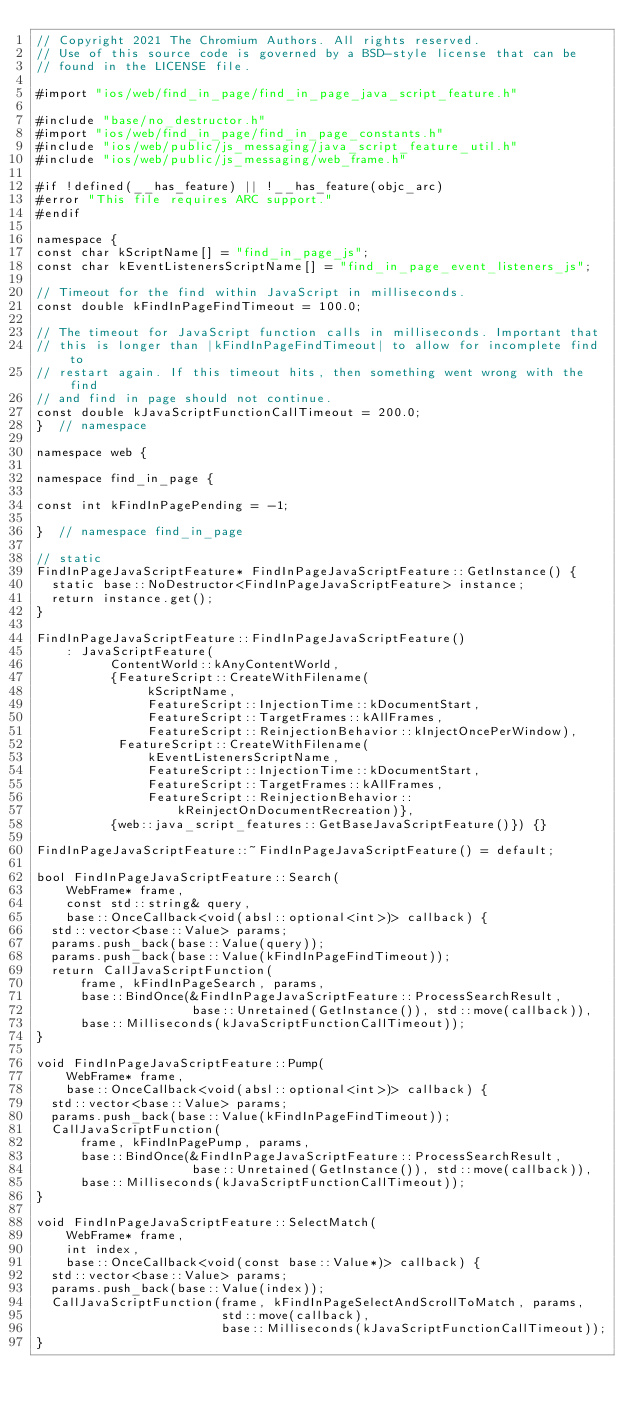Convert code to text. <code><loc_0><loc_0><loc_500><loc_500><_ObjectiveC_>// Copyright 2021 The Chromium Authors. All rights reserved.
// Use of this source code is governed by a BSD-style license that can be
// found in the LICENSE file.

#import "ios/web/find_in_page/find_in_page_java_script_feature.h"

#include "base/no_destructor.h"
#import "ios/web/find_in_page/find_in_page_constants.h"
#include "ios/web/public/js_messaging/java_script_feature_util.h"
#include "ios/web/public/js_messaging/web_frame.h"

#if !defined(__has_feature) || !__has_feature(objc_arc)
#error "This file requires ARC support."
#endif

namespace {
const char kScriptName[] = "find_in_page_js";
const char kEventListenersScriptName[] = "find_in_page_event_listeners_js";

// Timeout for the find within JavaScript in milliseconds.
const double kFindInPageFindTimeout = 100.0;

// The timeout for JavaScript function calls in milliseconds. Important that
// this is longer than |kFindInPageFindTimeout| to allow for incomplete find to
// restart again. If this timeout hits, then something went wrong with the find
// and find in page should not continue.
const double kJavaScriptFunctionCallTimeout = 200.0;
}  // namespace

namespace web {

namespace find_in_page {

const int kFindInPagePending = -1;

}  // namespace find_in_page

// static
FindInPageJavaScriptFeature* FindInPageJavaScriptFeature::GetInstance() {
  static base::NoDestructor<FindInPageJavaScriptFeature> instance;
  return instance.get();
}

FindInPageJavaScriptFeature::FindInPageJavaScriptFeature()
    : JavaScriptFeature(
          ContentWorld::kAnyContentWorld,
          {FeatureScript::CreateWithFilename(
               kScriptName,
               FeatureScript::InjectionTime::kDocumentStart,
               FeatureScript::TargetFrames::kAllFrames,
               FeatureScript::ReinjectionBehavior::kInjectOncePerWindow),
           FeatureScript::CreateWithFilename(
               kEventListenersScriptName,
               FeatureScript::InjectionTime::kDocumentStart,
               FeatureScript::TargetFrames::kAllFrames,
               FeatureScript::ReinjectionBehavior::
                   kReinjectOnDocumentRecreation)},
          {web::java_script_features::GetBaseJavaScriptFeature()}) {}

FindInPageJavaScriptFeature::~FindInPageJavaScriptFeature() = default;

bool FindInPageJavaScriptFeature::Search(
    WebFrame* frame,
    const std::string& query,
    base::OnceCallback<void(absl::optional<int>)> callback) {
  std::vector<base::Value> params;
  params.push_back(base::Value(query));
  params.push_back(base::Value(kFindInPageFindTimeout));
  return CallJavaScriptFunction(
      frame, kFindInPageSearch, params,
      base::BindOnce(&FindInPageJavaScriptFeature::ProcessSearchResult,
                     base::Unretained(GetInstance()), std::move(callback)),
      base::Milliseconds(kJavaScriptFunctionCallTimeout));
}

void FindInPageJavaScriptFeature::Pump(
    WebFrame* frame,
    base::OnceCallback<void(absl::optional<int>)> callback) {
  std::vector<base::Value> params;
  params.push_back(base::Value(kFindInPageFindTimeout));
  CallJavaScriptFunction(
      frame, kFindInPagePump, params,
      base::BindOnce(&FindInPageJavaScriptFeature::ProcessSearchResult,
                     base::Unretained(GetInstance()), std::move(callback)),
      base::Milliseconds(kJavaScriptFunctionCallTimeout));
}

void FindInPageJavaScriptFeature::SelectMatch(
    WebFrame* frame,
    int index,
    base::OnceCallback<void(const base::Value*)> callback) {
  std::vector<base::Value> params;
  params.push_back(base::Value(index));
  CallJavaScriptFunction(frame, kFindInPageSelectAndScrollToMatch, params,
                         std::move(callback),
                         base::Milliseconds(kJavaScriptFunctionCallTimeout));
}
</code> 